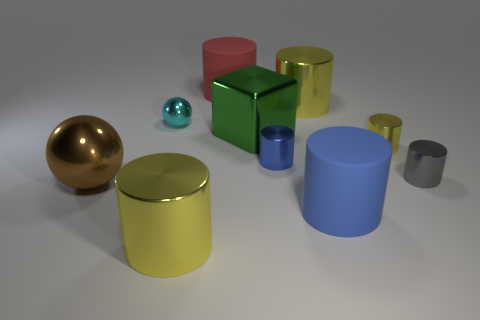Subtract all big rubber cylinders. How many cylinders are left? 5 Subtract all red cubes. How many blue cylinders are left? 2 Subtract all blue cylinders. How many cylinders are left? 5 Subtract all cylinders. How many objects are left? 3 Add 4 yellow cylinders. How many yellow cylinders exist? 7 Subtract 0 cyan cubes. How many objects are left? 10 Subtract all yellow balls. Subtract all gray cylinders. How many balls are left? 2 Subtract all large rubber cylinders. Subtract all big yellow metallic objects. How many objects are left? 6 Add 5 tiny metal spheres. How many tiny metal spheres are left? 6 